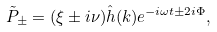Convert formula to latex. <formula><loc_0><loc_0><loc_500><loc_500>\tilde { P } _ { \pm } = ( \xi \pm i \nu ) \hat { h } ( { k } ) e ^ { - i \omega t \pm 2 i \Phi } ,</formula> 